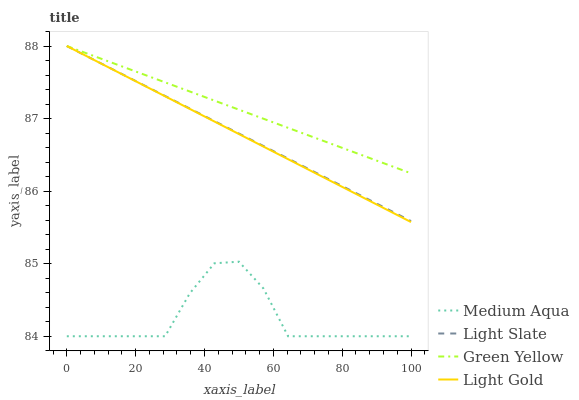Does Medium Aqua have the minimum area under the curve?
Answer yes or no. Yes. Does Green Yellow have the maximum area under the curve?
Answer yes or no. Yes. Does Light Gold have the minimum area under the curve?
Answer yes or no. No. Does Light Gold have the maximum area under the curve?
Answer yes or no. No. Is Light Gold the smoothest?
Answer yes or no. Yes. Is Medium Aqua the roughest?
Answer yes or no. Yes. Is Green Yellow the smoothest?
Answer yes or no. No. Is Green Yellow the roughest?
Answer yes or no. No. Does Medium Aqua have the lowest value?
Answer yes or no. Yes. Does Light Gold have the lowest value?
Answer yes or no. No. Does Green Yellow have the highest value?
Answer yes or no. Yes. Does Medium Aqua have the highest value?
Answer yes or no. No. Is Medium Aqua less than Light Gold?
Answer yes or no. Yes. Is Light Gold greater than Medium Aqua?
Answer yes or no. Yes. Does Light Gold intersect Light Slate?
Answer yes or no. Yes. Is Light Gold less than Light Slate?
Answer yes or no. No. Is Light Gold greater than Light Slate?
Answer yes or no. No. Does Medium Aqua intersect Light Gold?
Answer yes or no. No. 